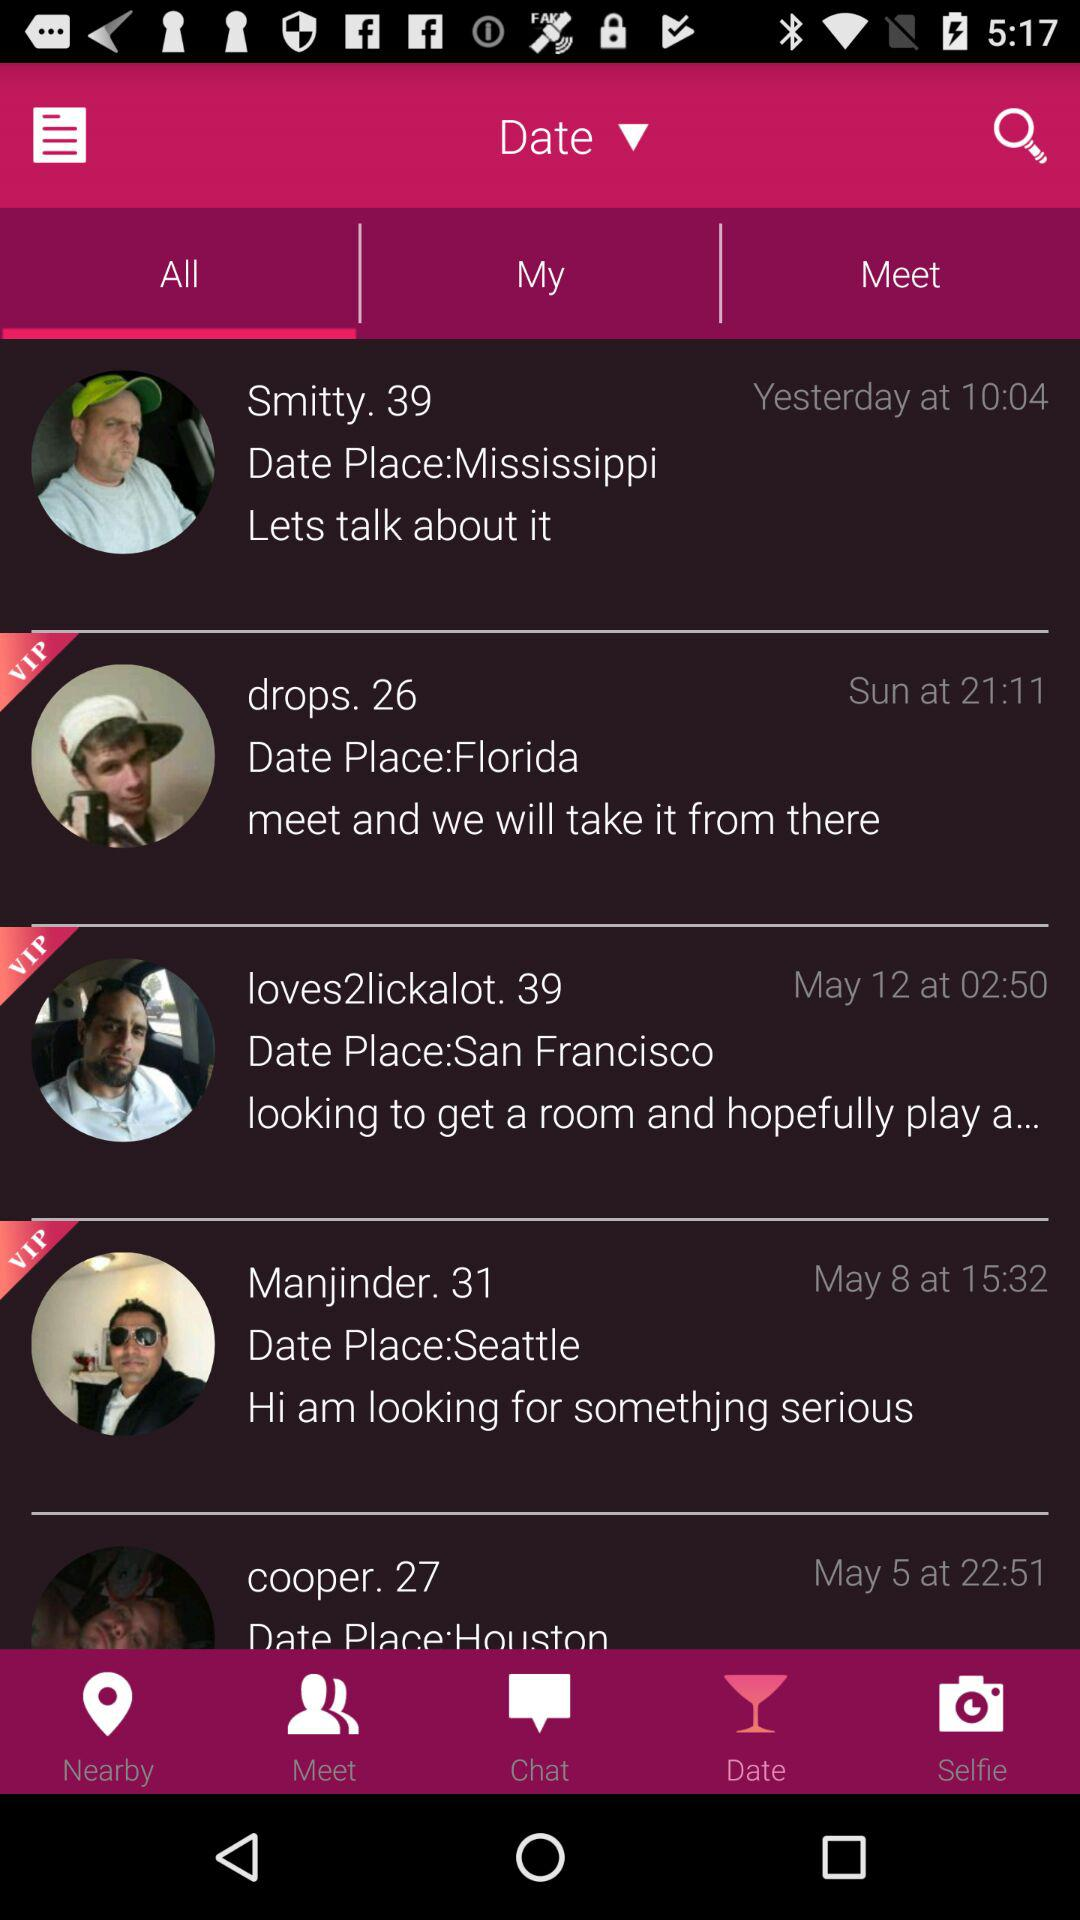Who was born at San Francisco?
When the provided information is insufficient, respond with <no answer>. <no answer> 